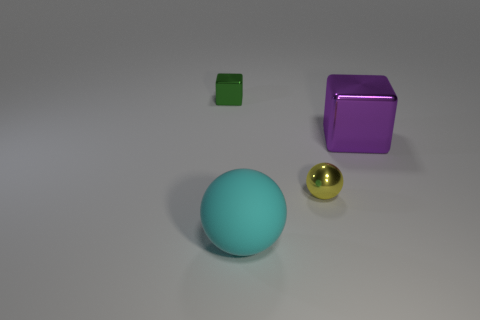How many shiny objects are the same color as the metal sphere?
Offer a terse response. 0. There is a big shiny cube; is it the same color as the big object on the left side of the large metallic cube?
Make the answer very short. No. Are there more brown things than green shiny objects?
Offer a very short reply. No. There is a green metal thing that is the same shape as the big purple metallic object; what size is it?
Offer a very short reply. Small. Is the tiny yellow object made of the same material as the cube to the right of the cyan object?
Provide a succinct answer. Yes. How many things are gray cubes or spheres?
Offer a very short reply. 2. Do the metal block behind the large purple shiny block and the object that is in front of the small ball have the same size?
Your answer should be compact. No. How many balls are shiny objects or small green things?
Your answer should be very brief. 1. Are any small yellow spheres visible?
Your response must be concise. Yes. Is there any other thing that is the same shape as the tiny yellow object?
Your answer should be very brief. Yes. 